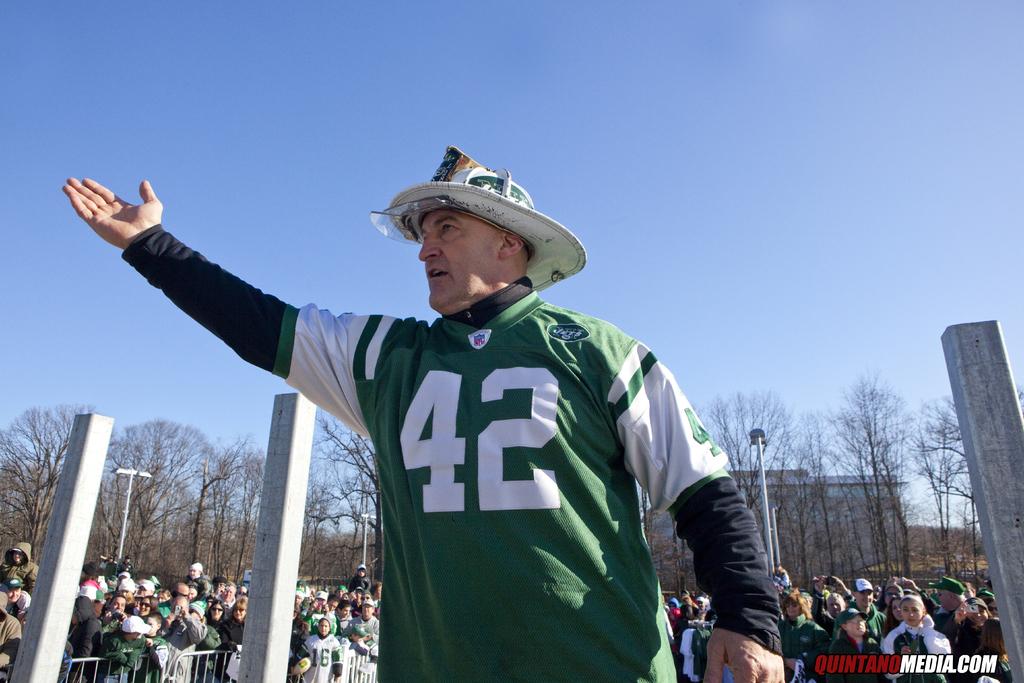Which team is he a fan of?
Your response must be concise. Jets. Which team has the color of green and white that this man is wearing?
Ensure brevity in your answer.  Jets. 